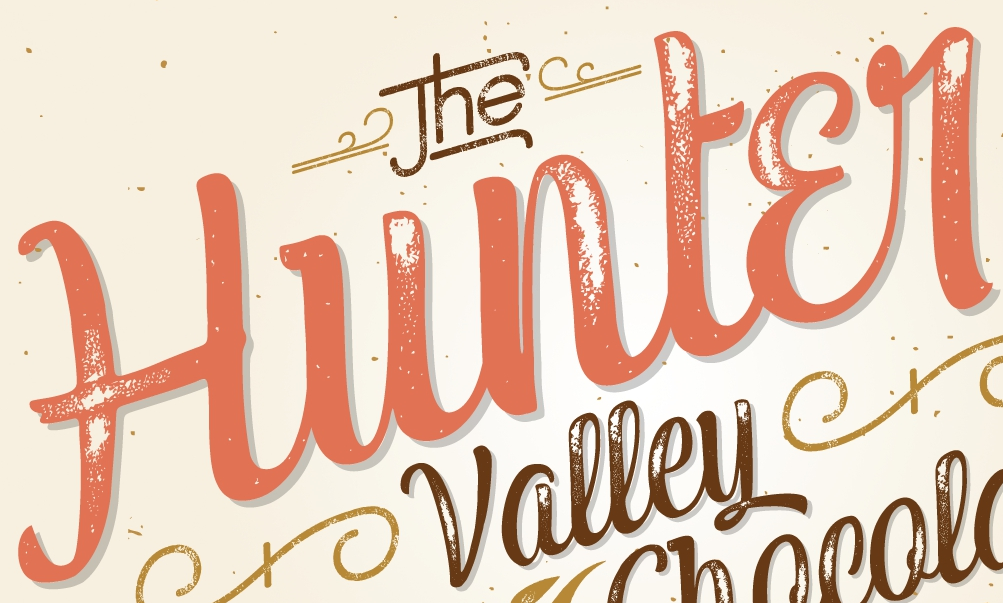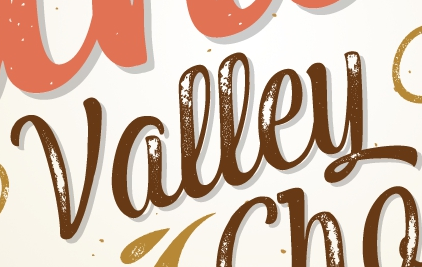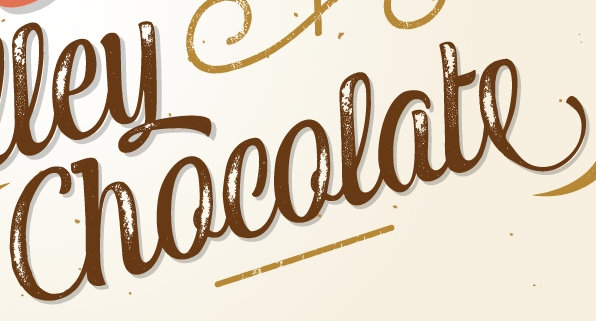What words can you see in these images in sequence, separated by a semicolon? Hunter; Valley; Chocolate 